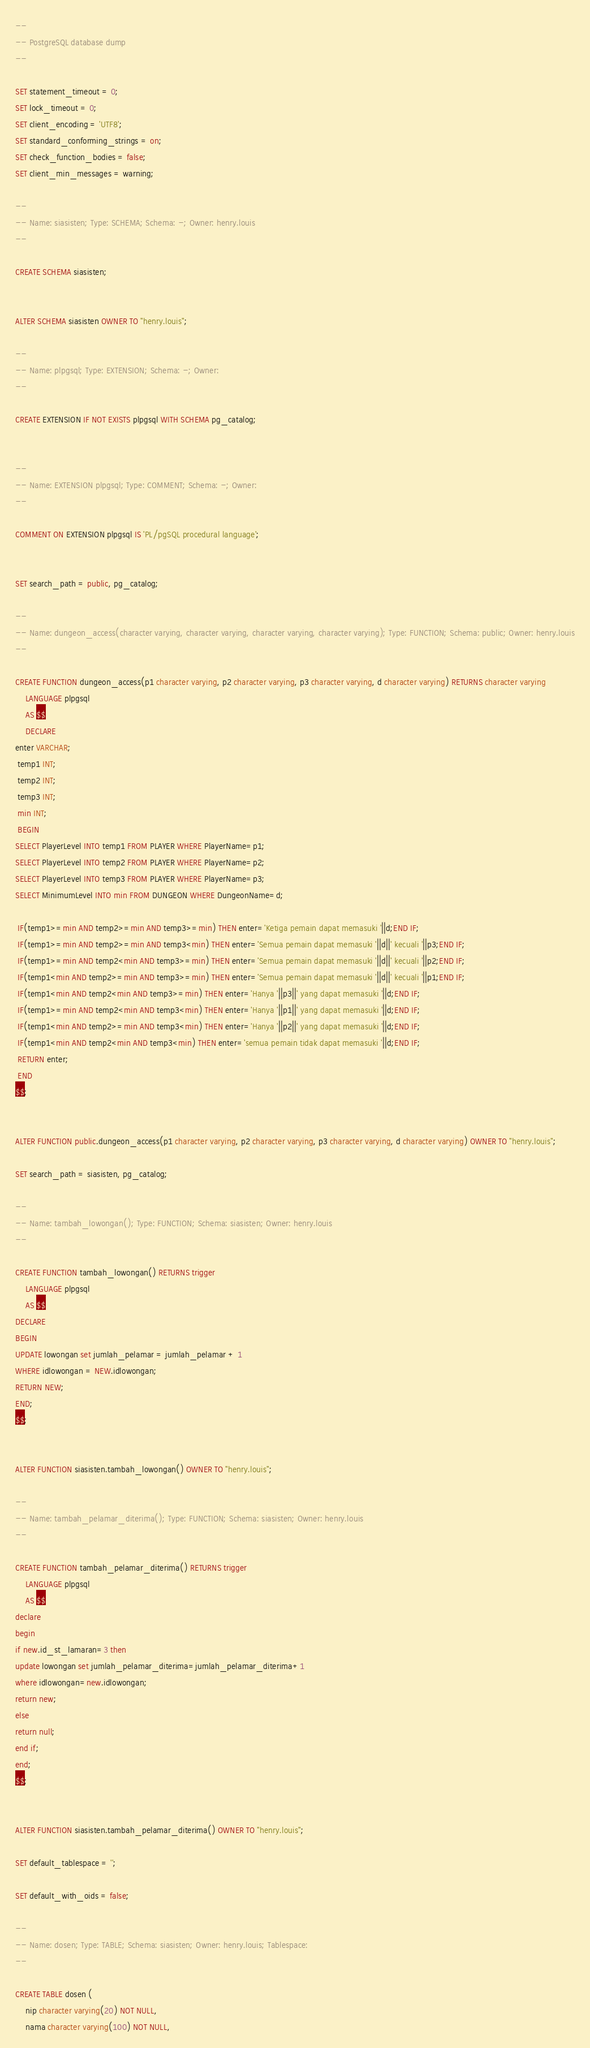<code> <loc_0><loc_0><loc_500><loc_500><_SQL_>--
-- PostgreSQL database dump
--

SET statement_timeout = 0;
SET lock_timeout = 0;
SET client_encoding = 'UTF8';
SET standard_conforming_strings = on;
SET check_function_bodies = false;
SET client_min_messages = warning;

--
-- Name: siasisten; Type: SCHEMA; Schema: -; Owner: henry.louis
--

CREATE SCHEMA siasisten;


ALTER SCHEMA siasisten OWNER TO "henry.louis";

--
-- Name: plpgsql; Type: EXTENSION; Schema: -; Owner: 
--

CREATE EXTENSION IF NOT EXISTS plpgsql WITH SCHEMA pg_catalog;


--
-- Name: EXTENSION plpgsql; Type: COMMENT; Schema: -; Owner: 
--

COMMENT ON EXTENSION plpgsql IS 'PL/pgSQL procedural language';


SET search_path = public, pg_catalog;

--
-- Name: dungeon_access(character varying, character varying, character varying, character varying); Type: FUNCTION; Schema: public; Owner: henry.louis
--

CREATE FUNCTION dungeon_access(p1 character varying, p2 character varying, p3 character varying, d character varying) RETURNS character varying
    LANGUAGE plpgsql
    AS $$
    DECLARE
enter VARCHAR;
 temp1 INT;
 temp2 INT;
 temp3 INT;
 min INT;
 BEGIN
SELECT PlayerLevel INTO temp1 FROM PLAYER WHERE PlayerName=p1;
SELECT PlayerLevel INTO temp2 FROM PLAYER WHERE PlayerName=p2;
SELECT PlayerLevel INTO temp3 FROM PLAYER WHERE PlayerName=p3;
SELECT MinimumLevel INTO min FROM DUNGEON WHERE DungeonName=d;
 
 IF(temp1>=min AND temp2>=min AND temp3>=min) THEN enter='Ketiga pemain dapat memasuki '||d;END IF;
 IF(temp1>=min AND temp2>=min AND temp3<min) THEN enter='Semua pemain dapat memasuki '||d||' kecuali '||p3;END IF;
 IF(temp1>=min AND temp2<min AND temp3>=min) THEN enter='Semua pemain dapat memasuki '||d||' kecuali '||p2;END IF;
 IF(temp1<min AND temp2>=min AND temp3>=min) THEN enter='Semua pemain dapat memasuki '||d||' kecuali '||p1;END IF;
 IF(temp1<min AND temp2<min AND temp3>=min) THEN enter='Hanya '||p3||' yang dapat memasuki '||d;END IF;
 IF(temp1>=min AND temp2<min AND temp3<min) THEN enter='Hanya '||p1||' yang dapat memasuki '||d;END IF;
 IF(temp1<min AND temp2>=min AND temp3<min) THEN enter='Hanya '||p2||' yang dapat memasuki '||d;END IF;
 IF(temp1<min AND temp2<min AND temp3<min) THEN enter='semua pemain tidak dapat memasuki '||d;END IF;
 RETURN enter;
 END
$$;


ALTER FUNCTION public.dungeon_access(p1 character varying, p2 character varying, p3 character varying, d character varying) OWNER TO "henry.louis";

SET search_path = siasisten, pg_catalog;

--
-- Name: tambah_lowongan(); Type: FUNCTION; Schema: siasisten; Owner: henry.louis
--

CREATE FUNCTION tambah_lowongan() RETURNS trigger
    LANGUAGE plpgsql
    AS $$
DECLARE
BEGIN
UPDATE lowongan set jumlah_pelamar = jumlah_pelamar + 1
WHERE idlowongan = NEW.idlowongan;
RETURN NEW;
END;
$$;


ALTER FUNCTION siasisten.tambah_lowongan() OWNER TO "henry.louis";

--
-- Name: tambah_pelamar_diterima(); Type: FUNCTION; Schema: siasisten; Owner: henry.louis
--

CREATE FUNCTION tambah_pelamar_diterima() RETURNS trigger
    LANGUAGE plpgsql
    AS $$
declare
begin
if new.id_st_lamaran=3 then
update lowongan set jumlah_pelamar_diterima=jumlah_pelamar_diterima+1
where idlowongan=new.idlowongan;
return new;
else
return null;
end if;
end;
$$;


ALTER FUNCTION siasisten.tambah_pelamar_diterima() OWNER TO "henry.louis";

SET default_tablespace = '';

SET default_with_oids = false;

--
-- Name: dosen; Type: TABLE; Schema: siasisten; Owner: henry.louis; Tablespace: 
--

CREATE TABLE dosen (
    nip character varying(20) NOT NULL,
    nama character varying(100) NOT NULL,</code> 